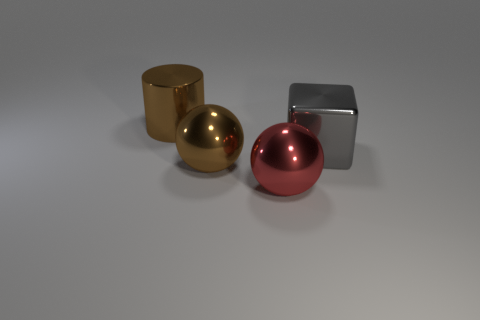Is there any other thing that has the same size as the metal block?
Your answer should be very brief. Yes. There is a brown metal object in front of the brown cylinder; what shape is it?
Provide a succinct answer. Sphere. How many other gray things are the same shape as the gray metal thing?
Provide a succinct answer. 0. Are there the same number of big brown metal cylinders that are behind the brown cylinder and gray objects behind the gray block?
Keep it short and to the point. Yes. Are there any brown things made of the same material as the big cube?
Offer a very short reply. Yes. Is the large cylinder made of the same material as the large red object?
Your answer should be very brief. Yes. How many red things are large metallic cylinders or big shiny balls?
Keep it short and to the point. 1. Are there more big brown metal things left of the big metal cylinder than cubes?
Offer a terse response. No. Are there any metallic blocks that have the same color as the large metal cylinder?
Offer a very short reply. No. The brown metallic ball has what size?
Your response must be concise. Large. 